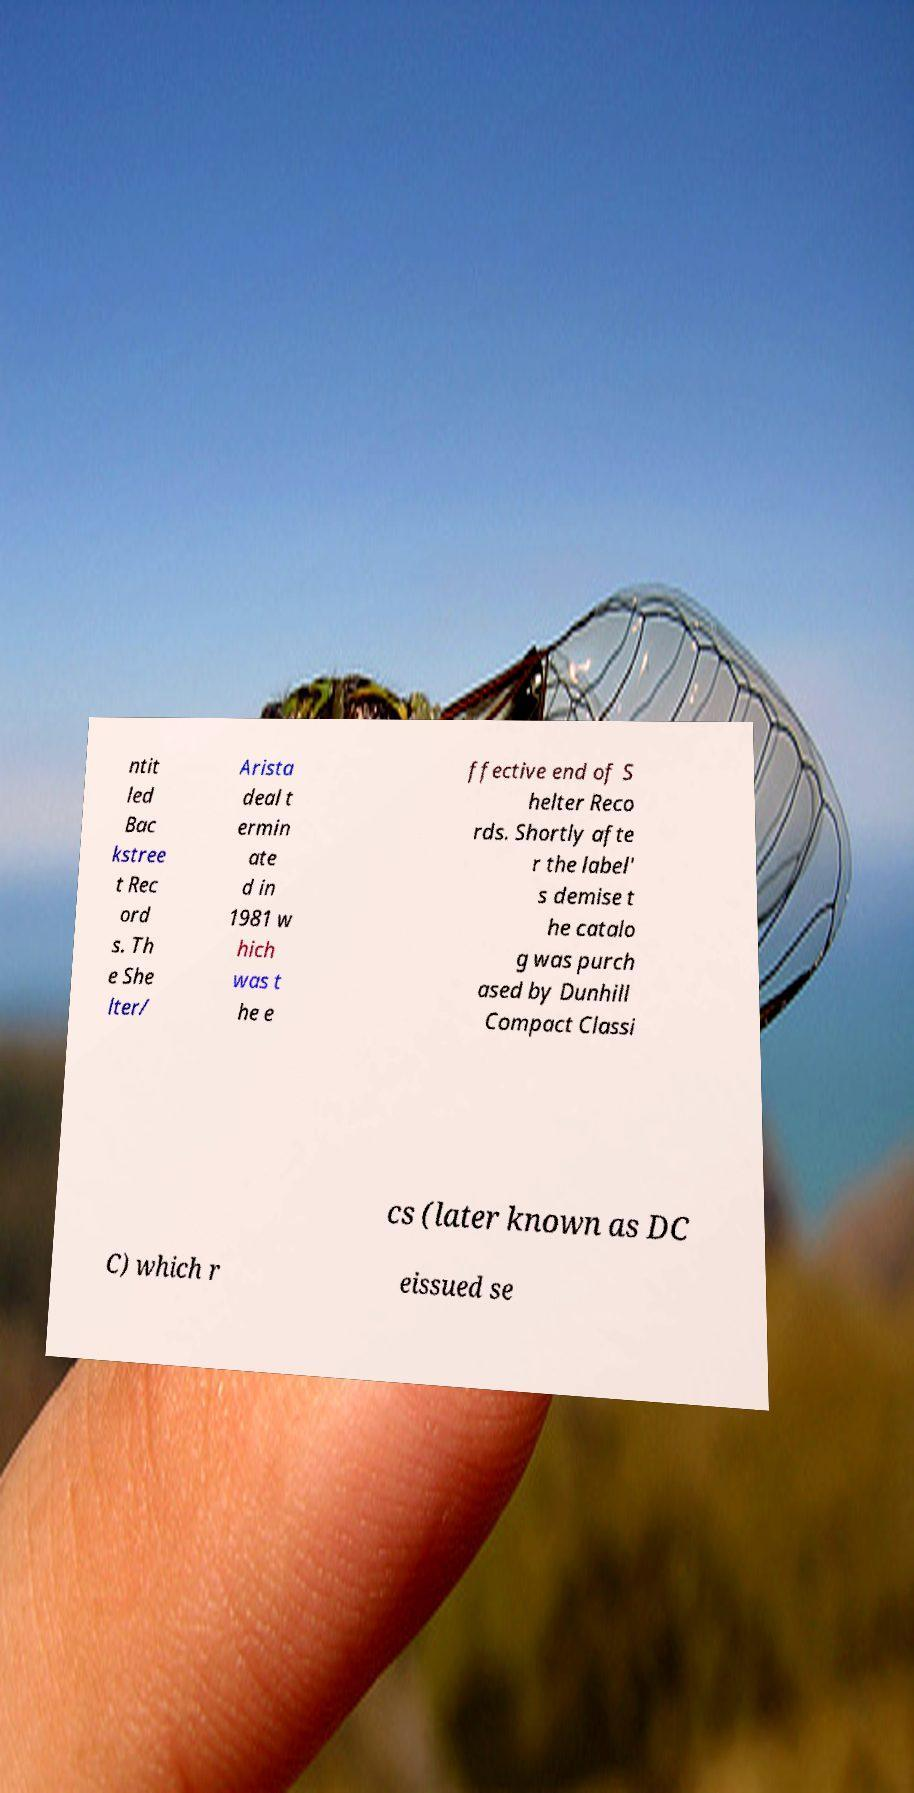What messages or text are displayed in this image? I need them in a readable, typed format. ntit led Bac kstree t Rec ord s. Th e She lter/ Arista deal t ermin ate d in 1981 w hich was t he e ffective end of S helter Reco rds. Shortly afte r the label' s demise t he catalo g was purch ased by Dunhill Compact Classi cs (later known as DC C) which r eissued se 